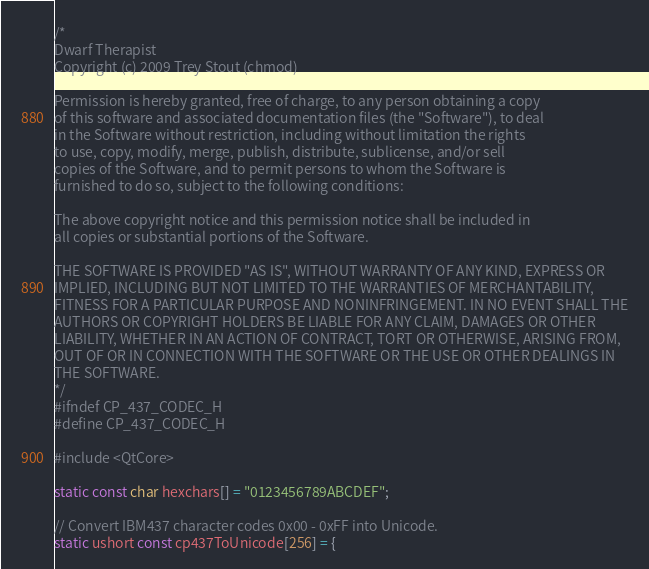<code> <loc_0><loc_0><loc_500><loc_500><_C_>/*
Dwarf Therapist
Copyright (c) 2009 Trey Stout (chmod)

Permission is hereby granted, free of charge, to any person obtaining a copy
of this software and associated documentation files (the "Software"), to deal
in the Software without restriction, including without limitation the rights
to use, copy, modify, merge, publish, distribute, sublicense, and/or sell
copies of the Software, and to permit persons to whom the Software is
furnished to do so, subject to the following conditions:

The above copyright notice and this permission notice shall be included in
all copies or substantial portions of the Software.

THE SOFTWARE IS PROVIDED "AS IS", WITHOUT WARRANTY OF ANY KIND, EXPRESS OR
IMPLIED, INCLUDING BUT NOT LIMITED TO THE WARRANTIES OF MERCHANTABILITY,
FITNESS FOR A PARTICULAR PURPOSE AND NONINFRINGEMENT. IN NO EVENT SHALL THE
AUTHORS OR COPYRIGHT HOLDERS BE LIABLE FOR ANY CLAIM, DAMAGES OR OTHER
LIABILITY, WHETHER IN AN ACTION OF CONTRACT, TORT OR OTHERWISE, ARISING FROM,
OUT OF OR IN CONNECTION WITH THE SOFTWARE OR THE USE OR OTHER DEALINGS IN
THE SOFTWARE.
*/
#ifndef CP_437_CODEC_H
#define CP_437_CODEC_H

#include <QtCore>

static const char hexchars[] = "0123456789ABCDEF";

// Convert IBM437 character codes 0x00 - 0xFF into Unicode.
static ushort const cp437ToUnicode[256] = {</code> 